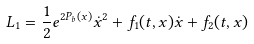<formula> <loc_0><loc_0><loc_500><loc_500>L _ { 1 } = \frac { 1 } { 2 } e ^ { 2 P _ { b } ( x ) } \dot { x } ^ { 2 } + f _ { 1 } ( t , x ) \dot { x } + f _ { 2 } ( t , x )</formula> 